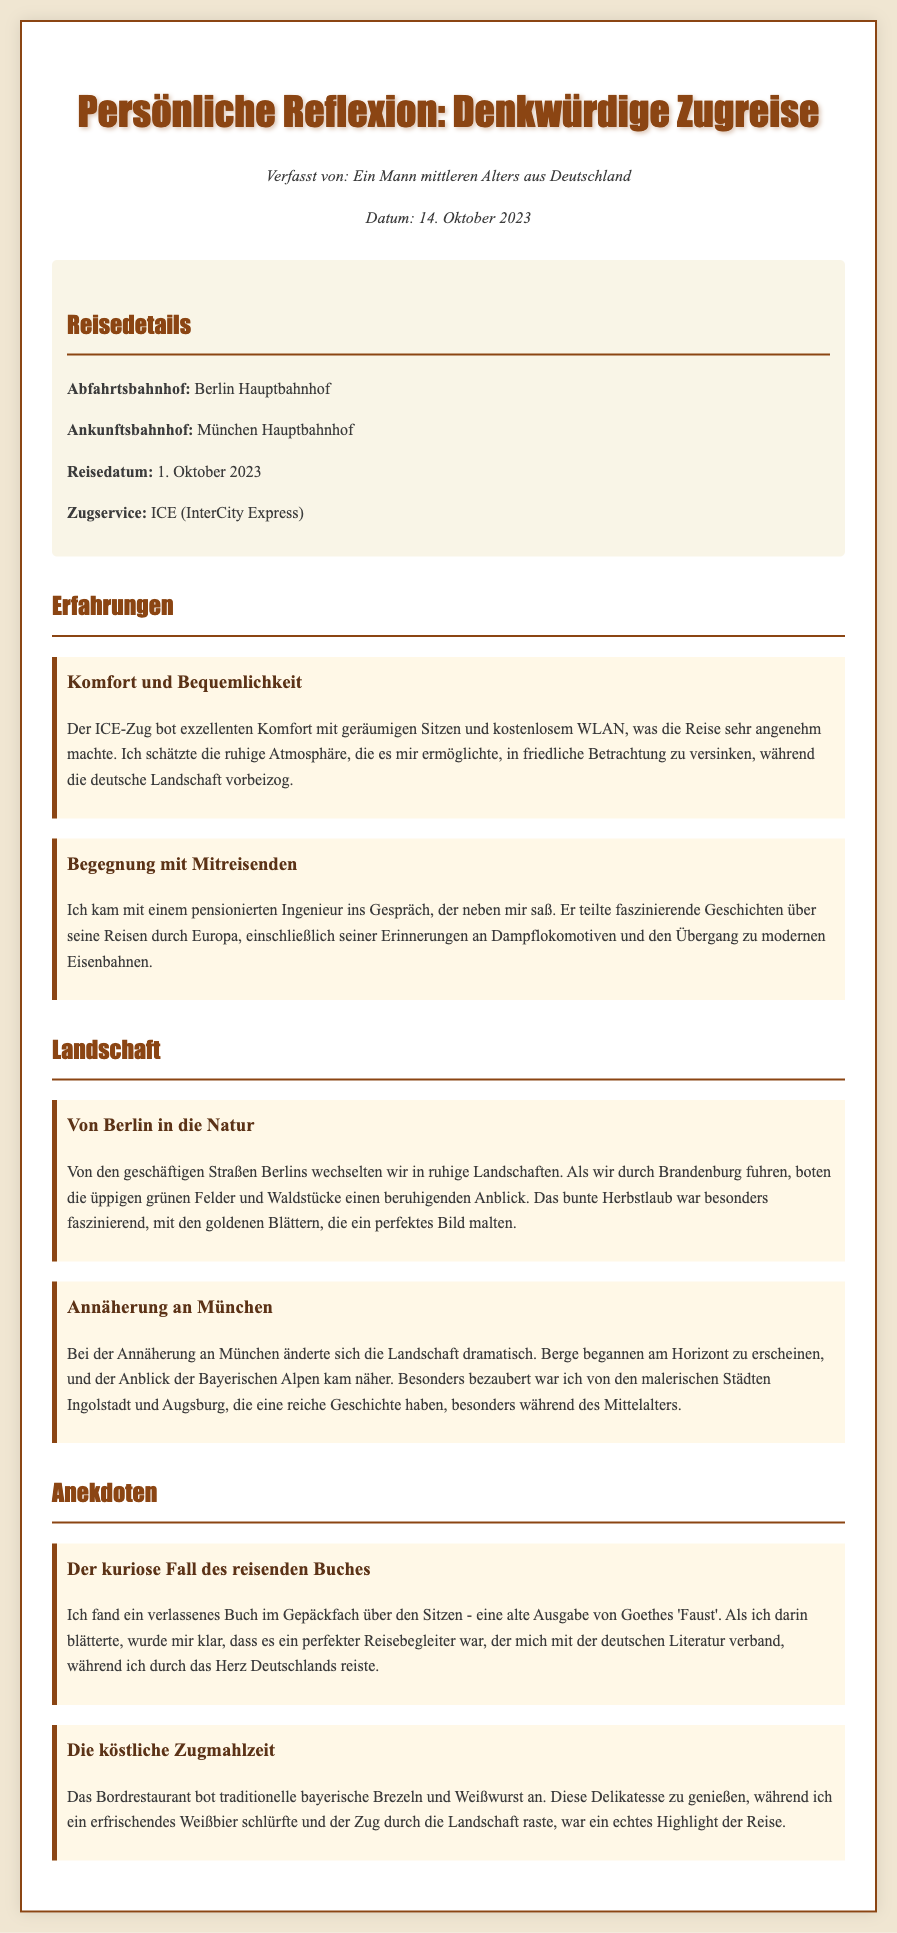What is the departure station? The document specifies that the journey started at Berlin Hauptbahnhof.
Answer: Berlin Hauptbahnhof What is the arrival station? According to the memo, the train trip ended at München Hauptbahnhof.
Answer: München Hauptbahnhof What date did the trip occur? The document indicates the trip took place on 1. Oktober 2023.
Answer: 1. Oktober 2023 What type of train was used for the journey? The memo states that the train service was ICE (InterCity Express).
Answer: ICE (InterCity Express) Who did the author converse with during the trip? The author mentioned a conversation with a pensionierten Ingenieur.
Answer: pensionierten Ingenieur What landscape did the author experience while departing from Berlin? The memo describes a transition to ruhige Landschaften.
Answer: ruhige Landschaften What traditional food did the author enjoy on the train? The document mentions that the Bordrestaurant offered bayerische Brezeln und Weißwurst.
Answer: bayerische Brezeln und Weißwurst What curious item did the author find while traveling? The author discovered a verlassenes Buch about Goethes 'Faust'.
Answer: verlassenes Buch What was a highlight of the trip for the author? The memo highlights enjoying a refreshing Weißbier while traveling.
Answer: Weißbier 